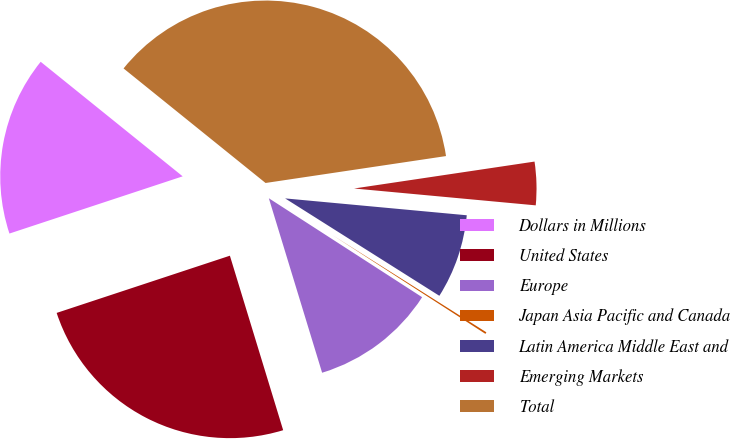<chart> <loc_0><loc_0><loc_500><loc_500><pie_chart><fcel>Dollars in Millions<fcel>United States<fcel>Europe<fcel>Japan Asia Pacific and Canada<fcel>Latin America Middle East and<fcel>Emerging Markets<fcel>Total<nl><fcel>15.88%<fcel>24.64%<fcel>11.16%<fcel>0.16%<fcel>7.49%<fcel>3.83%<fcel>36.84%<nl></chart> 